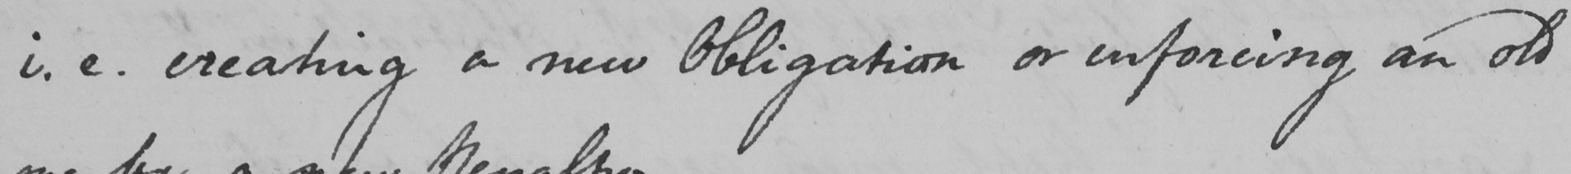What is written in this line of handwriting? i.e . creating a new Obligation or enforcing an old 